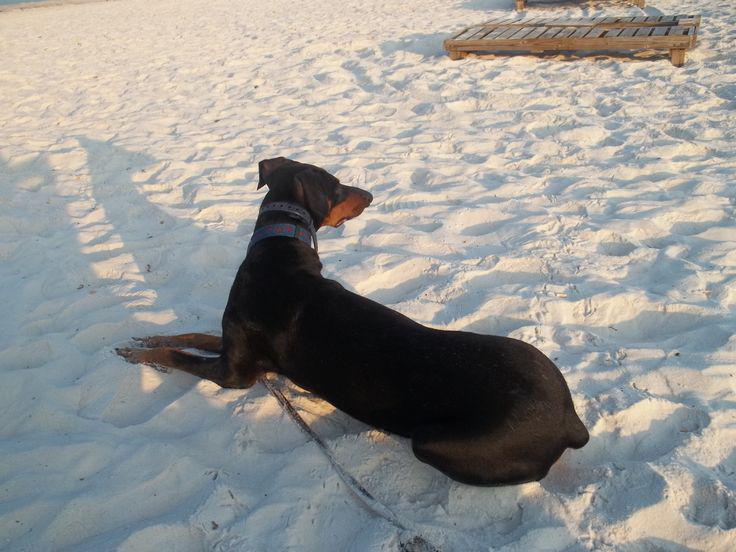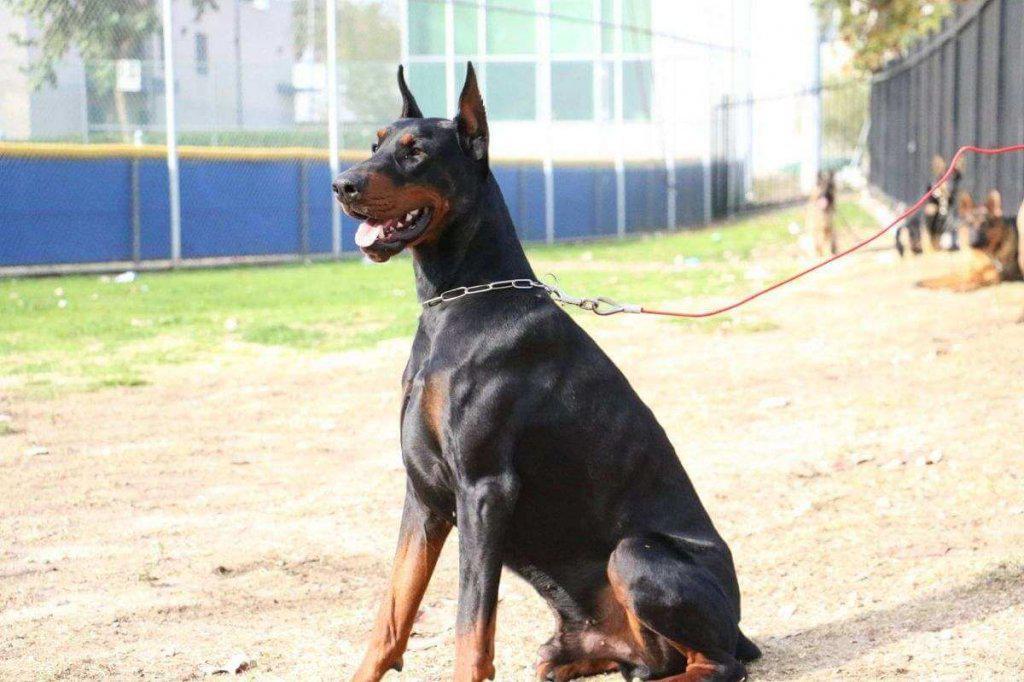The first image is the image on the left, the second image is the image on the right. For the images shown, is this caption "Three dogs are sitting in the grass in one of the images." true? Answer yes or no. No. The first image is the image on the left, the second image is the image on the right. Considering the images on both sides, is "There are four dogs." valid? Answer yes or no. No. 